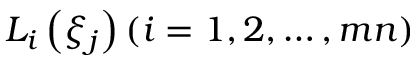<formula> <loc_0><loc_0><loc_500><loc_500>L _ { i } \left ( \xi _ { j } \right ) ( i = 1 , 2 , \dots , m n )</formula> 